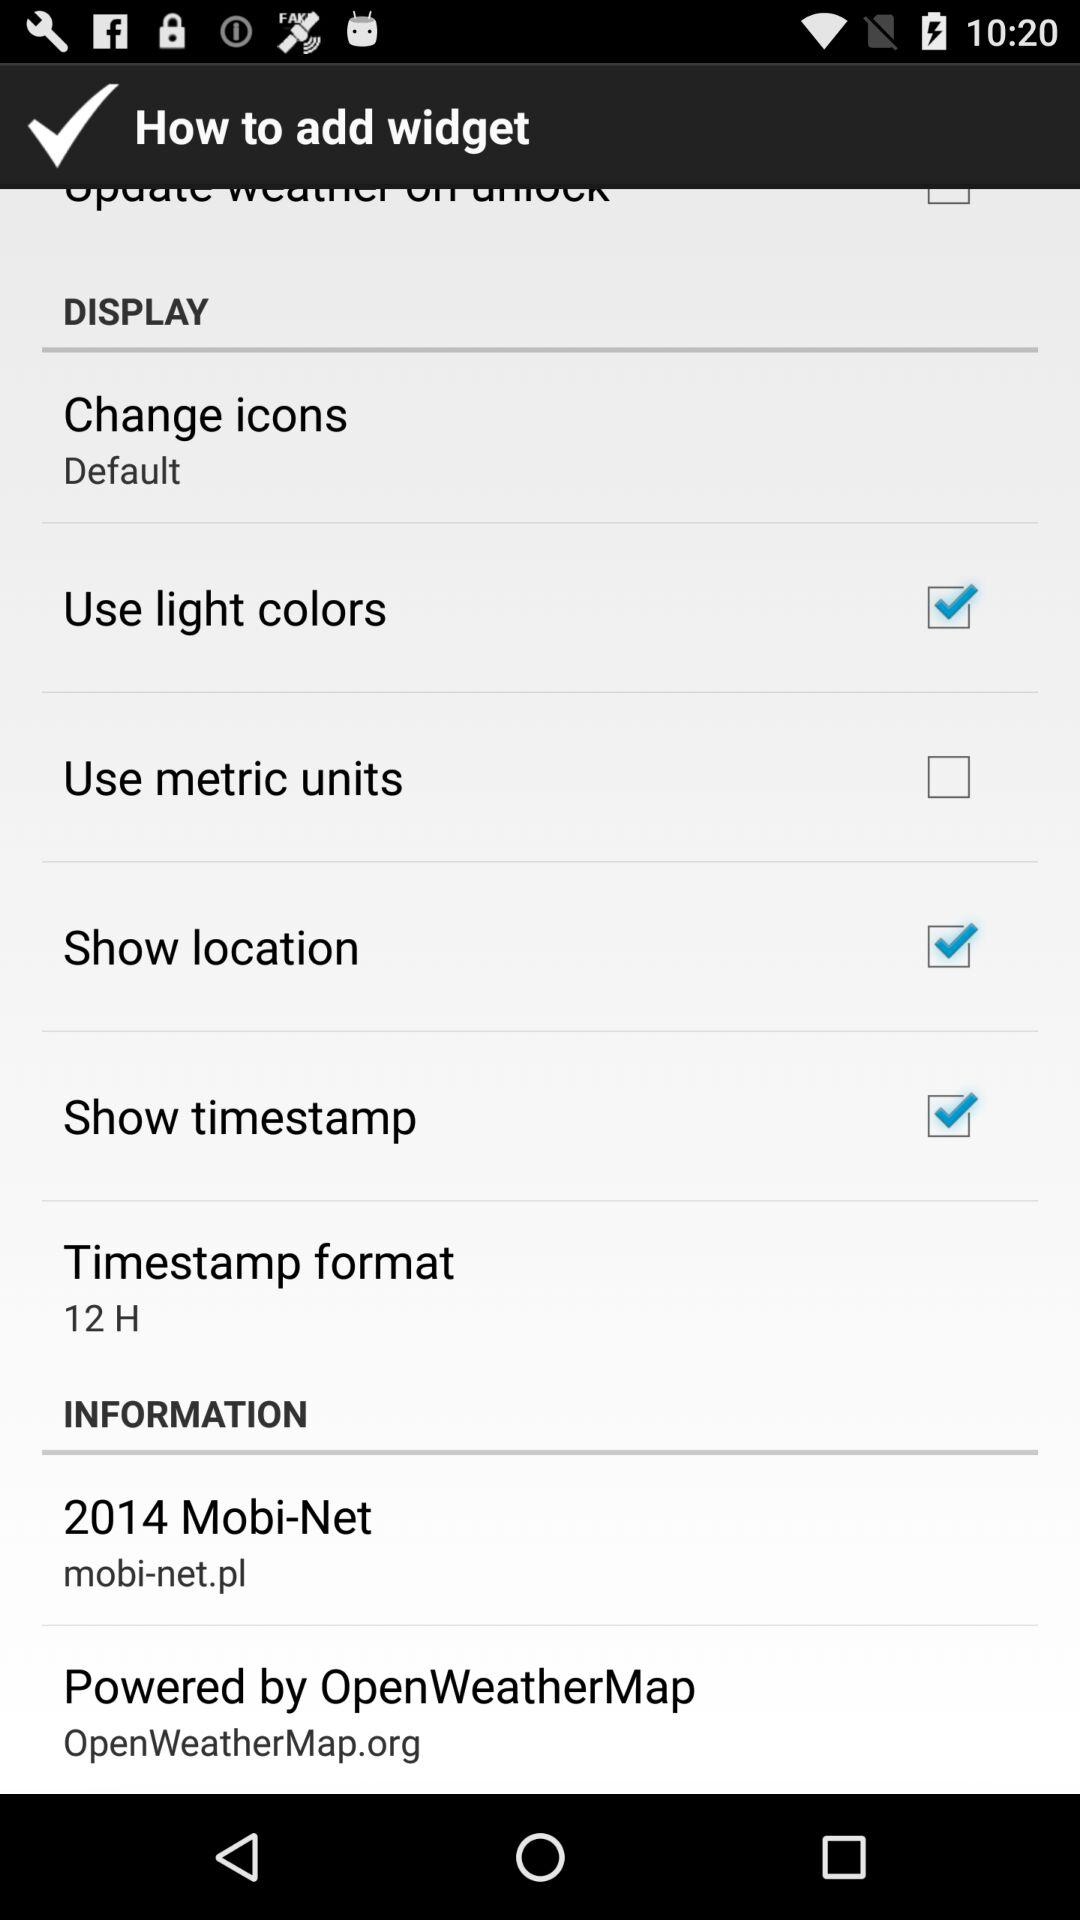Which checkbox is unchecked? The unchecked checkbox is "Use metric units". 